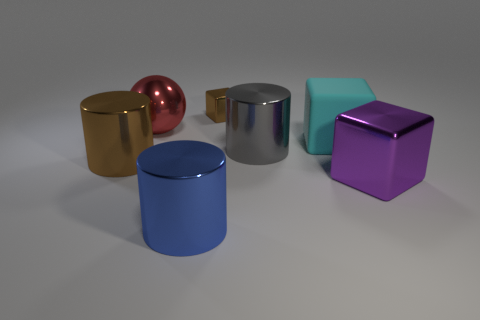Do the large red object and the brown object that is to the left of the blue cylinder have the same shape?
Provide a short and direct response. No. Is there a large red object of the same shape as the large brown thing?
Your response must be concise. No. What is the shape of the brown metal object that is in front of the big cube behind the purple thing?
Keep it short and to the point. Cylinder. There is a large metallic thing that is behind the gray metal object; what shape is it?
Offer a very short reply. Sphere. Is the color of the metallic cylinder that is behind the big brown object the same as the big shiny object that is to the right of the large cyan thing?
Offer a terse response. No. How many metal objects are both to the left of the big blue metal object and right of the big blue metallic thing?
Provide a succinct answer. 0. What is the size of the gray thing that is the same material as the big brown cylinder?
Your answer should be compact. Large. How big is the cyan object?
Offer a very short reply. Large. What is the small brown cube made of?
Your answer should be very brief. Metal. Do the brown thing to the left of the blue cylinder and the large purple shiny cube have the same size?
Your answer should be compact. Yes. 